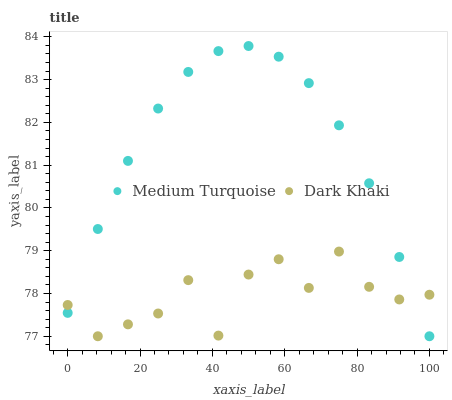Does Dark Khaki have the minimum area under the curve?
Answer yes or no. Yes. Does Medium Turquoise have the maximum area under the curve?
Answer yes or no. Yes. Does Medium Turquoise have the minimum area under the curve?
Answer yes or no. No. Is Medium Turquoise the smoothest?
Answer yes or no. Yes. Is Dark Khaki the roughest?
Answer yes or no. Yes. Is Medium Turquoise the roughest?
Answer yes or no. No. Does Dark Khaki have the lowest value?
Answer yes or no. Yes. Does Medium Turquoise have the highest value?
Answer yes or no. Yes. Does Medium Turquoise intersect Dark Khaki?
Answer yes or no. Yes. Is Medium Turquoise less than Dark Khaki?
Answer yes or no. No. Is Medium Turquoise greater than Dark Khaki?
Answer yes or no. No. 